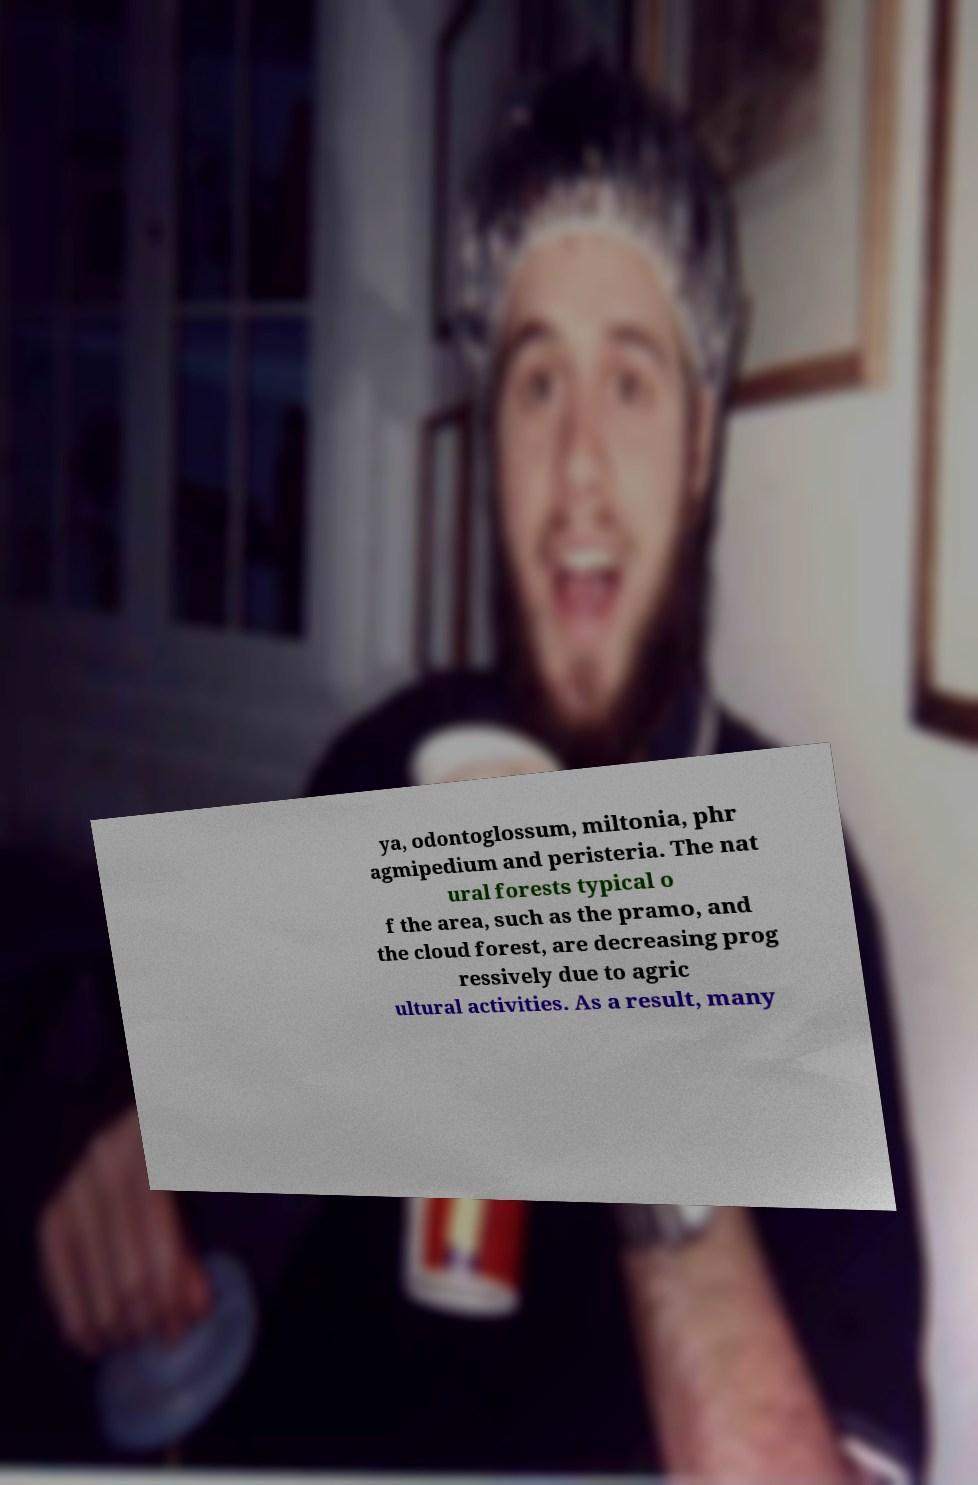Please read and relay the text visible in this image. What does it say? ya, odontoglossum, miltonia, phr agmipedium and peristeria. The nat ural forests typical o f the area, such as the pramo, and the cloud forest, are decreasing prog ressively due to agric ultural activities. As a result, many 